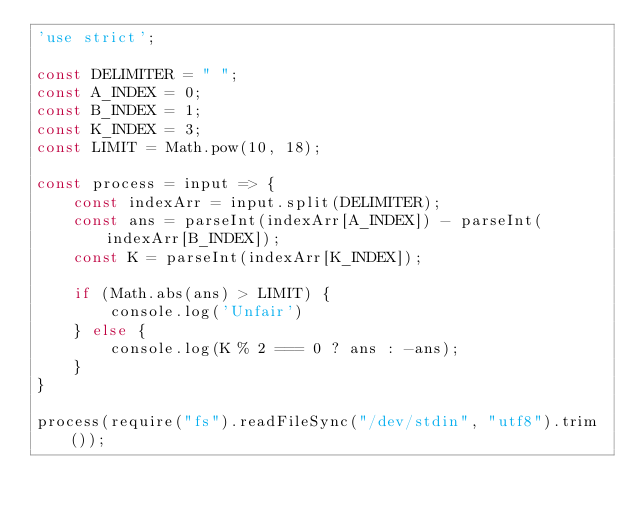Convert code to text. <code><loc_0><loc_0><loc_500><loc_500><_JavaScript_>'use strict';

const DELIMITER = " ";
const A_INDEX = 0;
const B_INDEX = 1;
const K_INDEX = 3;
const LIMIT = Math.pow(10, 18);

const process = input => {
    const indexArr = input.split(DELIMITER);
    const ans = parseInt(indexArr[A_INDEX]) - parseInt(indexArr[B_INDEX]);
    const K = parseInt(indexArr[K_INDEX]);

    if (Math.abs(ans) > LIMIT) {
        console.log('Unfair')
    } else {
        console.log(K % 2 === 0 ? ans : -ans);
    }
}

process(require("fs").readFileSync("/dev/stdin", "utf8").trim());</code> 